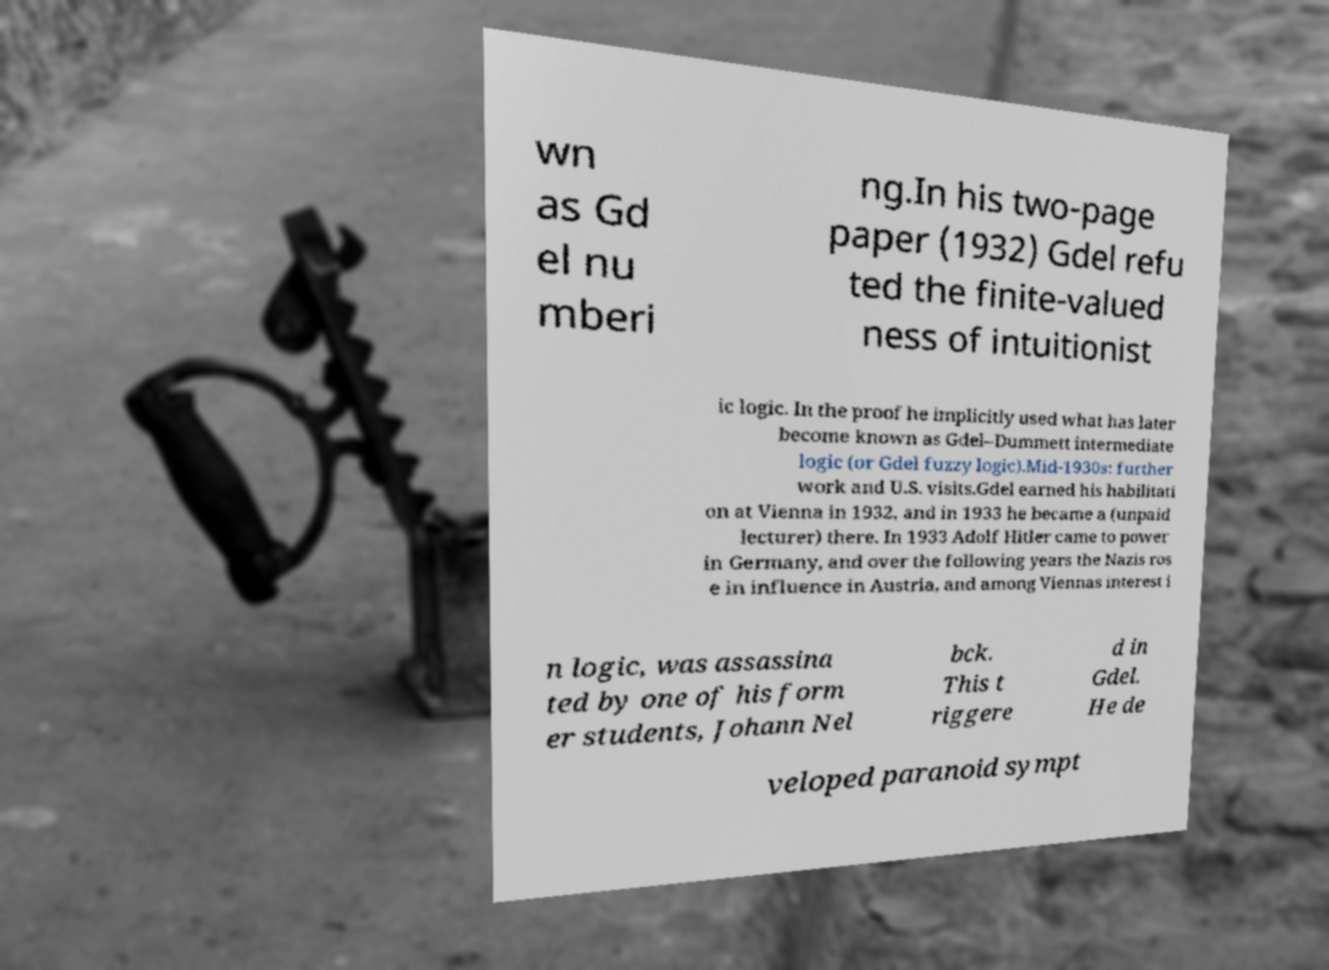Can you read and provide the text displayed in the image?This photo seems to have some interesting text. Can you extract and type it out for me? wn as Gd el nu mberi ng.In his two-page paper (1932) Gdel refu ted the finite-valued ness of intuitionist ic logic. In the proof he implicitly used what has later become known as Gdel–Dummett intermediate logic (or Gdel fuzzy logic).Mid-1930s: further work and U.S. visits.Gdel earned his habilitati on at Vienna in 1932, and in 1933 he became a (unpaid lecturer) there. In 1933 Adolf Hitler came to power in Germany, and over the following years the Nazis ros e in influence in Austria, and among Viennas interest i n logic, was assassina ted by one of his form er students, Johann Nel bck. This t riggere d in Gdel. He de veloped paranoid sympt 